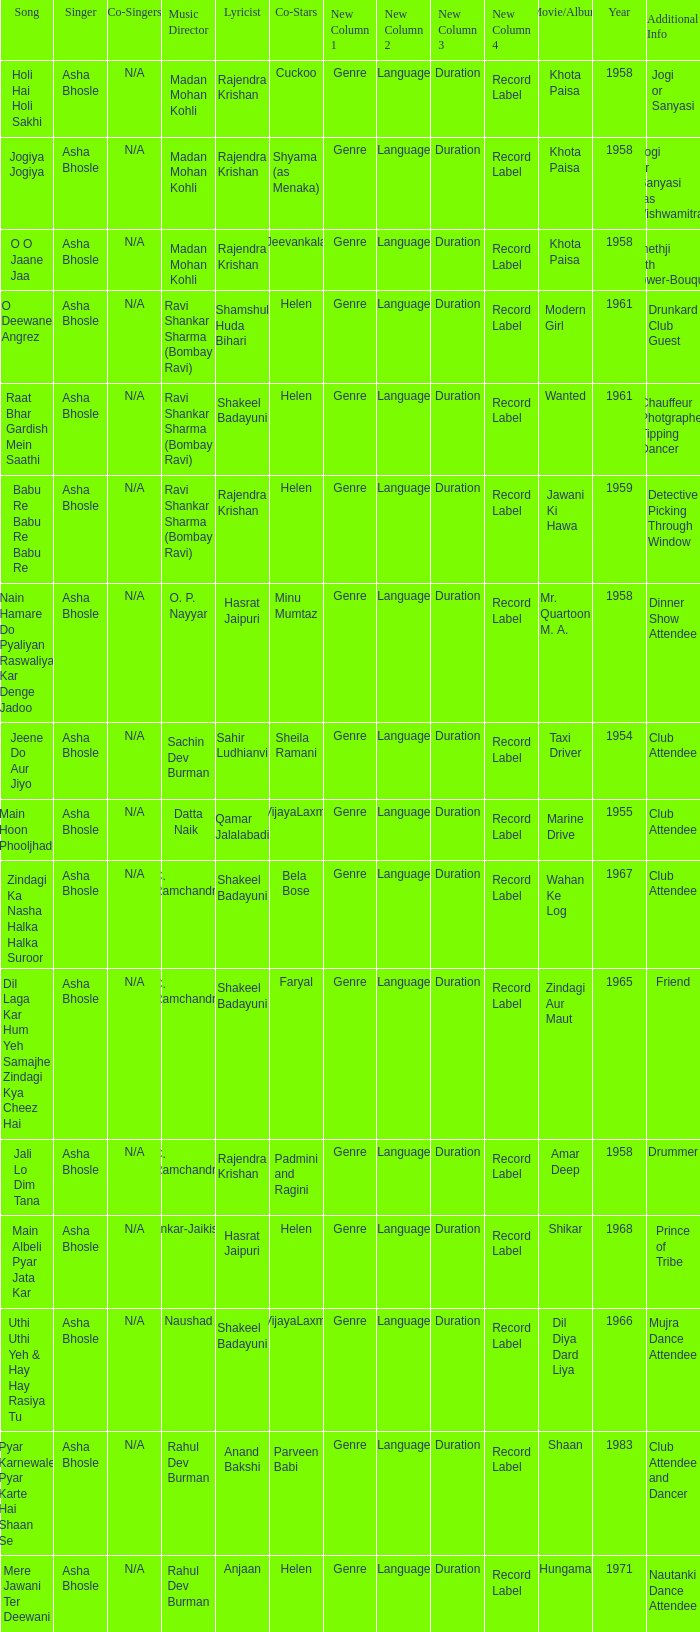Who wrote the lyrics when Jeevankala co-starred? Rajendra Krishan. 